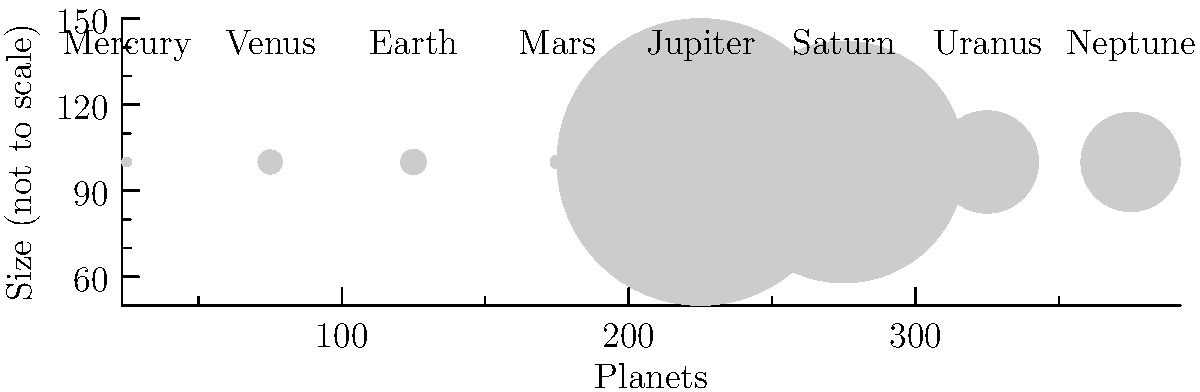Based on the scale comparison chart of planets in our solar system, which planet is the largest, and approximately how many times larger is its diameter compared to Earth's? To answer this question, let's follow these steps:

1. Observe the chart: The chart shows the relative sizes of the eight planets in our solar system, with their names labeled below each circle.

2. Identify the largest planet: Jupiter is clearly the largest circle in the chart, representing the largest planet in our solar system.

3. Compare Jupiter's size to Earth's:
   - Jupiter's diameter: 142,984 km
   - Earth's diameter: 12,756 km

4. Calculate the ratio:
   $\frac{\text{Jupiter's diameter}}{\text{Earth's diameter}} = \frac{142,984}{12,756} \approx 11.21$

5. Round to the nearest whole number: 11 times larger

This comparison demonstrates the vast size difference between Jupiter and Earth, highlighting Jupiter's status as a gas giant and Earth as a relatively small terrestrial planet.
Answer: Jupiter, approximately 11 times larger 